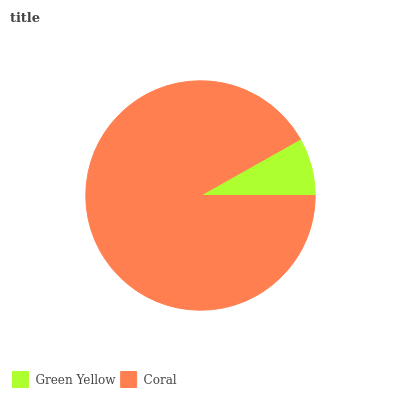Is Green Yellow the minimum?
Answer yes or no. Yes. Is Coral the maximum?
Answer yes or no. Yes. Is Coral the minimum?
Answer yes or no. No. Is Coral greater than Green Yellow?
Answer yes or no. Yes. Is Green Yellow less than Coral?
Answer yes or no. Yes. Is Green Yellow greater than Coral?
Answer yes or no. No. Is Coral less than Green Yellow?
Answer yes or no. No. Is Coral the high median?
Answer yes or no. Yes. Is Green Yellow the low median?
Answer yes or no. Yes. Is Green Yellow the high median?
Answer yes or no. No. Is Coral the low median?
Answer yes or no. No. 